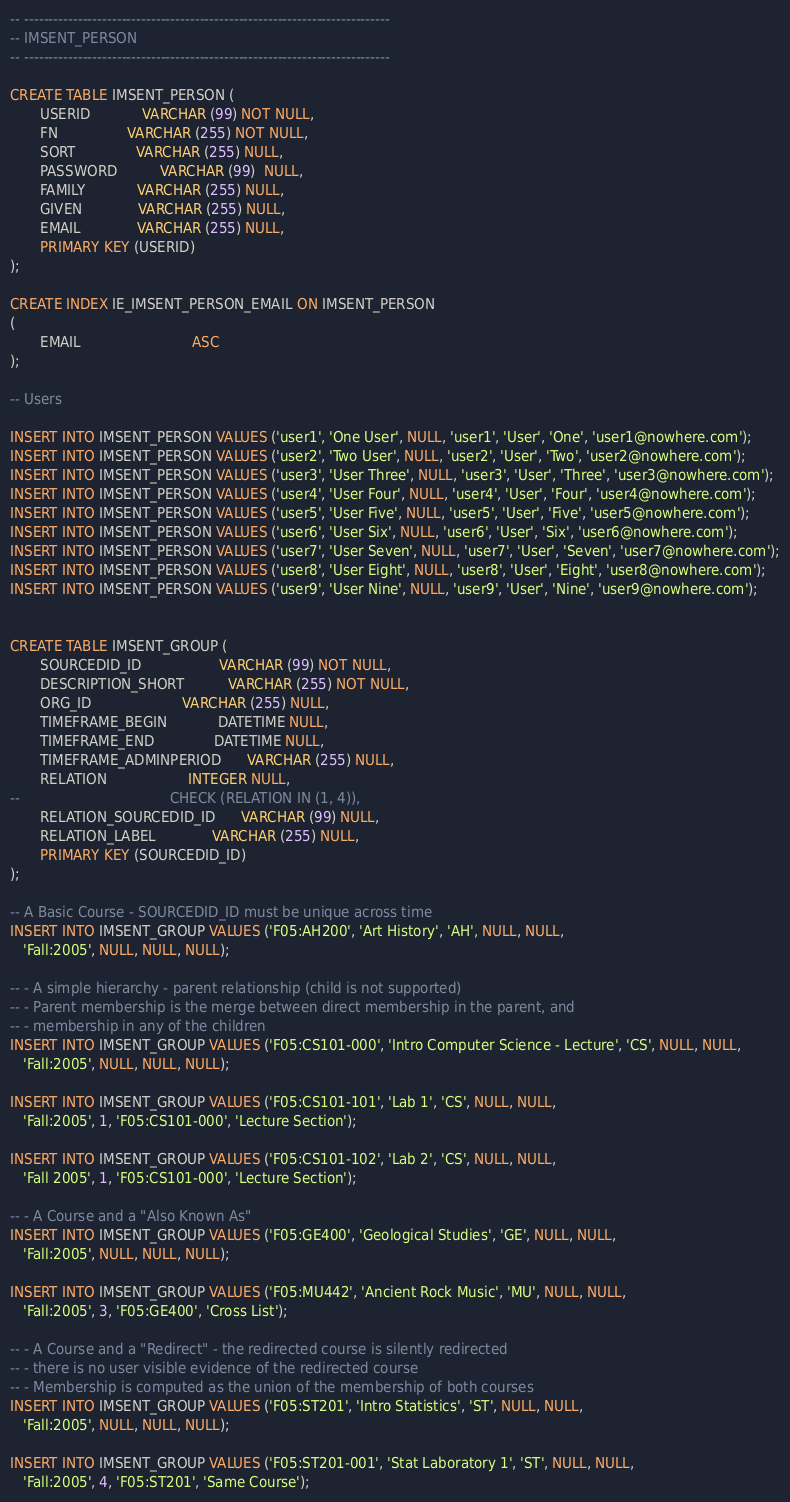<code> <loc_0><loc_0><loc_500><loc_500><_SQL_>-- ---------------------------------------------------------------------------
-- IMSENT_PERSON
-- ---------------------------------------------------------------------------

CREATE TABLE IMSENT_PERSON (
       USERID            VARCHAR (99) NOT NULL,
       FN                VARCHAR (255) NOT NULL,
       SORT              VARCHAR (255) NULL,
       PASSWORD          VARCHAR (99)  NULL,
       FAMILY            VARCHAR (255) NULL,
       GIVEN             VARCHAR (255) NULL,
       EMAIL             VARCHAR (255) NULL,
       PRIMARY KEY (USERID)
);

CREATE INDEX IE_IMSENT_PERSON_EMAIL ON IMSENT_PERSON
(
       EMAIL                          ASC
);

-- Users

INSERT INTO IMSENT_PERSON VALUES ('user1', 'One User', NULL, 'user1', 'User', 'One', 'user1@nowhere.com');
INSERT INTO IMSENT_PERSON VALUES ('user2', 'Two User', NULL, 'user2', 'User', 'Two', 'user2@nowhere.com');
INSERT INTO IMSENT_PERSON VALUES ('user3', 'User Three', NULL, 'user3', 'User', 'Three', 'user3@nowhere.com');
INSERT INTO IMSENT_PERSON VALUES ('user4', 'User Four', NULL, 'user4', 'User', 'Four', 'user4@nowhere.com');
INSERT INTO IMSENT_PERSON VALUES ('user5', 'User Five', NULL, 'user5', 'User', 'Five', 'user5@nowhere.com');
INSERT INTO IMSENT_PERSON VALUES ('user6', 'User Six', NULL, 'user6', 'User', 'Six', 'user6@nowhere.com');
INSERT INTO IMSENT_PERSON VALUES ('user7', 'User Seven', NULL, 'user7', 'User', 'Seven', 'user7@nowhere.com');
INSERT INTO IMSENT_PERSON VALUES ('user8', 'User Eight', NULL, 'user8', 'User', 'Eight', 'user8@nowhere.com');
INSERT INTO IMSENT_PERSON VALUES ('user9', 'User Nine', NULL, 'user9', 'User', 'Nine', 'user9@nowhere.com');


CREATE TABLE IMSENT_GROUP (
       SOURCEDID_ID                  VARCHAR (99) NOT NULL,
       DESCRIPTION_SHORT          VARCHAR (255) NOT NULL,
       ORG_ID                     VARCHAR (255) NULL,
       TIMEFRAME_BEGIN            DATETIME NULL,
       TIMEFRAME_END              DATETIME NULL,
       TIMEFRAME_ADMINPERIOD      VARCHAR (255) NULL,
       RELATION                   INTEGER NULL,
--                                   CHECK (RELATION IN (1, 4)),
       RELATION_SOURCEDID_ID      VARCHAR (99) NULL,
       RELATION_LABEL             VARCHAR (255) NULL,
       PRIMARY KEY (SOURCEDID_ID)
);

-- A Basic Course - SOURCEDID_ID must be unique across time
INSERT INTO IMSENT_GROUP VALUES ('F05:AH200', 'Art History', 'AH', NULL, NULL,
   'Fall:2005', NULL, NULL, NULL);

-- - A simple hierarchy - parent relationship (child is not supported)
-- - Parent membership is the merge between direct membership in the parent, and 
-- - membership in any of the children
INSERT INTO IMSENT_GROUP VALUES ('F05:CS101-000', 'Intro Computer Science - Lecture', 'CS', NULL, NULL,
   'Fall:2005', NULL, NULL, NULL);

INSERT INTO IMSENT_GROUP VALUES ('F05:CS101-101', 'Lab 1', 'CS', NULL, NULL,
   'Fall:2005', 1, 'F05:CS101-000', 'Lecture Section');

INSERT INTO IMSENT_GROUP VALUES ('F05:CS101-102', 'Lab 2', 'CS', NULL, NULL,
   'Fall 2005', 1, 'F05:CS101-000', 'Lecture Section');

-- - A Course and a "Also Known As"
INSERT INTO IMSENT_GROUP VALUES ('F05:GE400', 'Geological Studies', 'GE', NULL, NULL,
   'Fall:2005', NULL, NULL, NULL);

INSERT INTO IMSENT_GROUP VALUES ('F05:MU442', 'Ancient Rock Music', 'MU', NULL, NULL,
   'Fall:2005', 3, 'F05:GE400', 'Cross List');
   
-- - A Course and a "Redirect" - the redirected course is silently redirected
-- - there is no user visible evidence of the redirected course
-- - Membership is computed as the union of the membership of both courses
INSERT INTO IMSENT_GROUP VALUES ('F05:ST201', 'Intro Statistics', 'ST', NULL, NULL,
   'Fall:2005', NULL, NULL, NULL);

INSERT INTO IMSENT_GROUP VALUES ('F05:ST201-001', 'Stat Laboratory 1', 'ST', NULL, NULL,
   'Fall:2005', 4, 'F05:ST201', 'Same Course');
</code> 